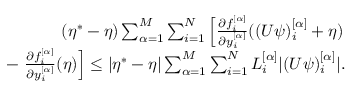<formula> <loc_0><loc_0><loc_500><loc_500>\begin{array} { r } { ( \eta ^ { * } - \eta ) \sum _ { \alpha = 1 } ^ { M } \sum _ { i = 1 } ^ { N } \left [ \frac { \partial f _ { i } ^ { [ \alpha ] } } { \partial y _ { i } ^ { [ \alpha ] } } ( ( U \psi ) _ { i } ^ { [ \alpha ] } + \eta ) } \\ { - \frac { \partial f _ { i } ^ { [ \alpha ] } } { \partial y _ { i } ^ { [ \alpha ] } } ( \eta ) \right ] \leq | \eta ^ { * } - \eta | \sum _ { \alpha = 1 } ^ { M } \sum _ { i = 1 } ^ { N } L _ { i } ^ { [ \alpha ] } | ( U \psi ) _ { i } ^ { [ \alpha ] } | . } \end{array}</formula> 